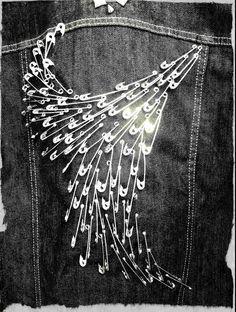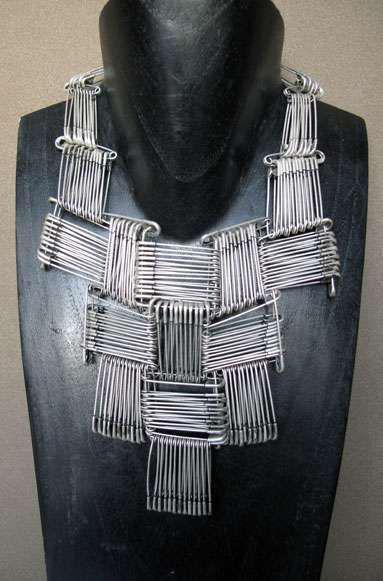The first image is the image on the left, the second image is the image on the right. Considering the images on both sides, is "The images show the backs of coats." valid? Answer yes or no. No. 